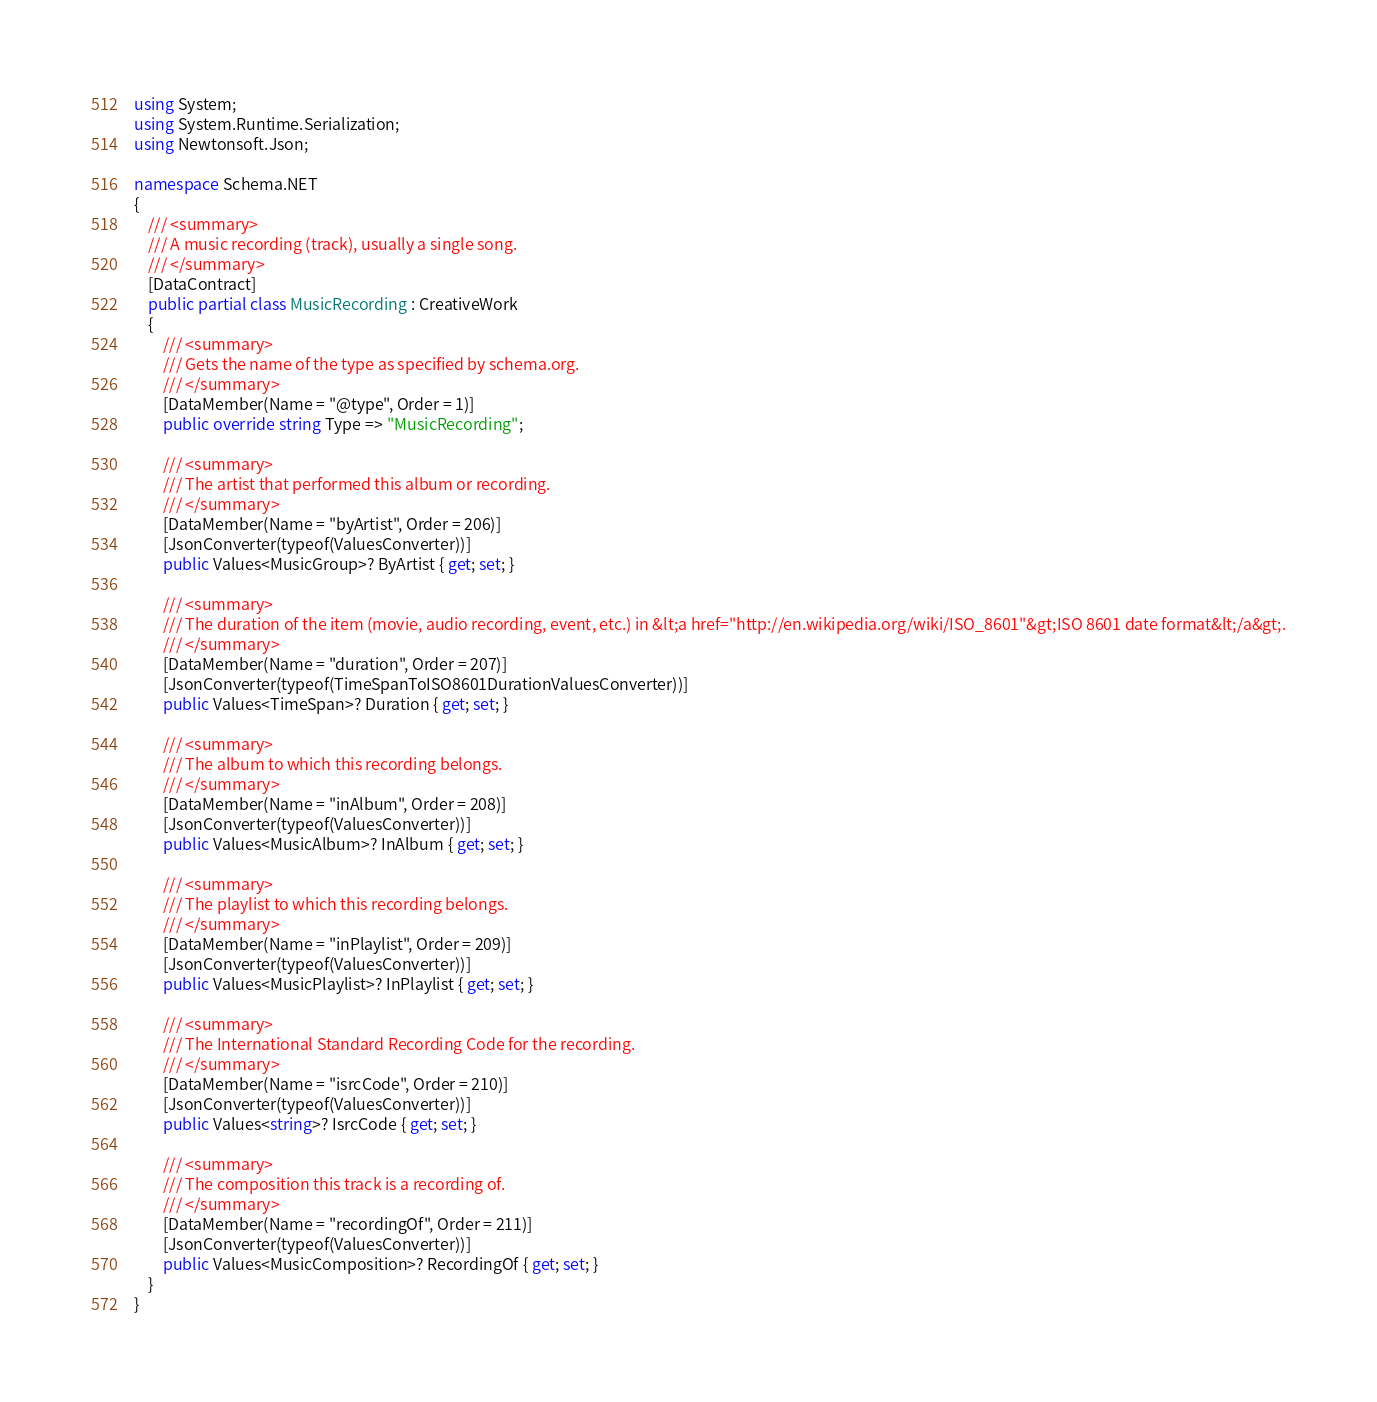<code> <loc_0><loc_0><loc_500><loc_500><_C#_>using System;
using System.Runtime.Serialization;
using Newtonsoft.Json;

namespace Schema.NET
{
    /// <summary>
    /// A music recording (track), usually a single song.
    /// </summary>
    [DataContract]
    public partial class MusicRecording : CreativeWork
    {
        /// <summary>
        /// Gets the name of the type as specified by schema.org.
        /// </summary>
        [DataMember(Name = "@type", Order = 1)]
        public override string Type => "MusicRecording";

        /// <summary>
        /// The artist that performed this album or recording.
        /// </summary>
        [DataMember(Name = "byArtist", Order = 206)]
        [JsonConverter(typeof(ValuesConverter))]
        public Values<MusicGroup>? ByArtist { get; set; } 

        /// <summary>
        /// The duration of the item (movie, audio recording, event, etc.) in &lt;a href="http://en.wikipedia.org/wiki/ISO_8601"&gt;ISO 8601 date format&lt;/a&gt;.
        /// </summary>
        [DataMember(Name = "duration", Order = 207)]
        [JsonConverter(typeof(TimeSpanToISO8601DurationValuesConverter))]
        public Values<TimeSpan>? Duration { get; set; } 

        /// <summary>
        /// The album to which this recording belongs.
        /// </summary>
        [DataMember(Name = "inAlbum", Order = 208)]
        [JsonConverter(typeof(ValuesConverter))]
        public Values<MusicAlbum>? InAlbum { get; set; } 

        /// <summary>
        /// The playlist to which this recording belongs.
        /// </summary>
        [DataMember(Name = "inPlaylist", Order = 209)]
        [JsonConverter(typeof(ValuesConverter))]
        public Values<MusicPlaylist>? InPlaylist { get; set; } 

        /// <summary>
        /// The International Standard Recording Code for the recording.
        /// </summary>
        [DataMember(Name = "isrcCode", Order = 210)]
        [JsonConverter(typeof(ValuesConverter))]
        public Values<string>? IsrcCode { get; set; } 

        /// <summary>
        /// The composition this track is a recording of.
        /// </summary>
        [DataMember(Name = "recordingOf", Order = 211)]
        [JsonConverter(typeof(ValuesConverter))]
        public Values<MusicComposition>? RecordingOf { get; set; } 
    }
}
</code> 